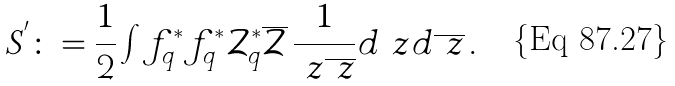Convert formula to latex. <formula><loc_0><loc_0><loc_500><loc_500>S ^ { ^ { \prime } } \colon = \frac { 1 } { 2 } \int f ^ { * } _ { q } f ^ { * } _ { q } \mathcal { Z } ^ { * } _ { q } \overline { \mathcal { Z } } \, \frac { 1 } { \ z \overline { \ z } } d \ z d \overline { \ z } \, .</formula> 